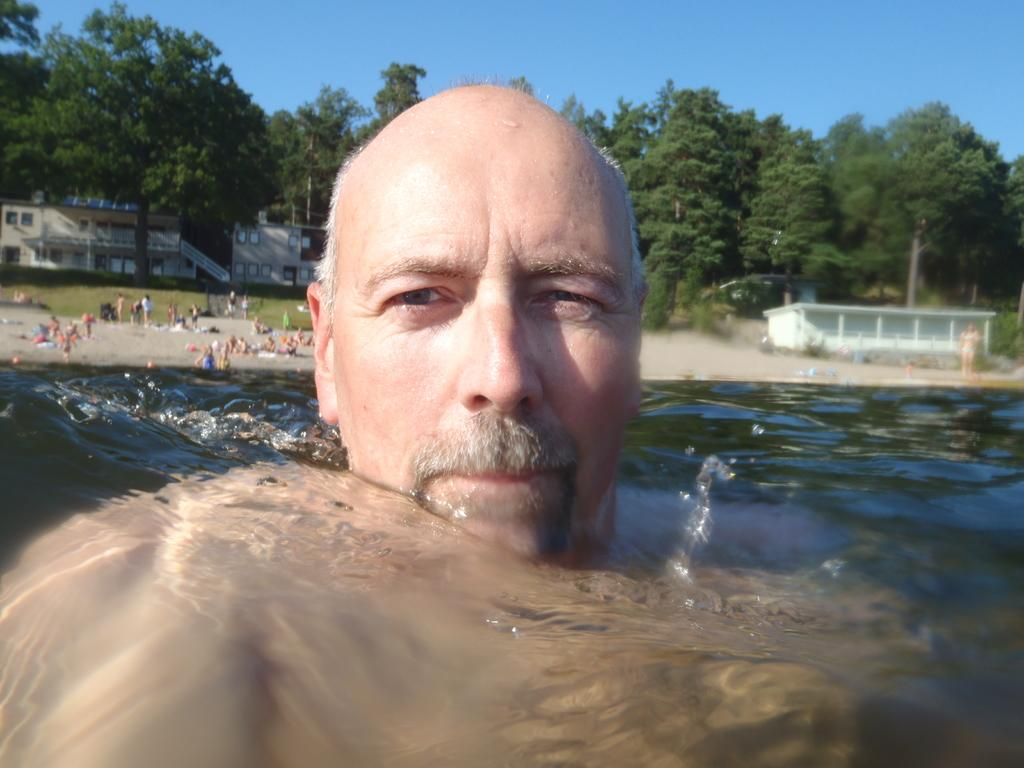What is the person in the image doing? The person is standing in the water in the image. What are the other people in the image doing? The other people are standing on the sand in the image. What type of natural environment can be seen in the image? There are trees visible in the image. What type of man-made structures can be seen in the image? There are buildings visible in the image. What type of force can be seen pushing the chair in the image? There is no chair present in the image, so no force can be seen pushing a chair. 